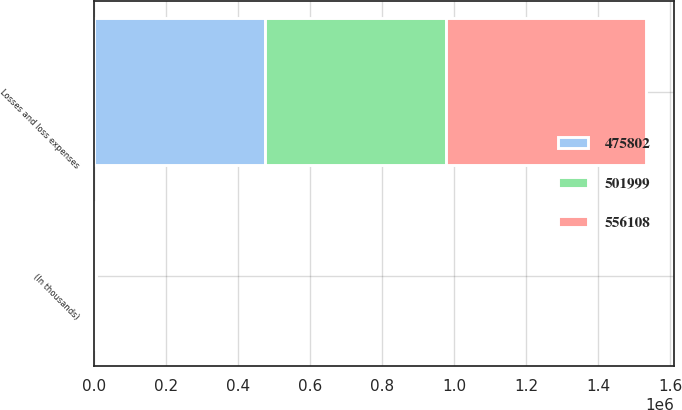Convert chart to OTSL. <chart><loc_0><loc_0><loc_500><loc_500><stacked_bar_chart><ecel><fcel>(In thousands)<fcel>Losses and loss expenses<nl><fcel>501999<fcel>2015<fcel>501999<nl><fcel>475802<fcel>2014<fcel>475802<nl><fcel>556108<fcel>2013<fcel>556108<nl></chart> 